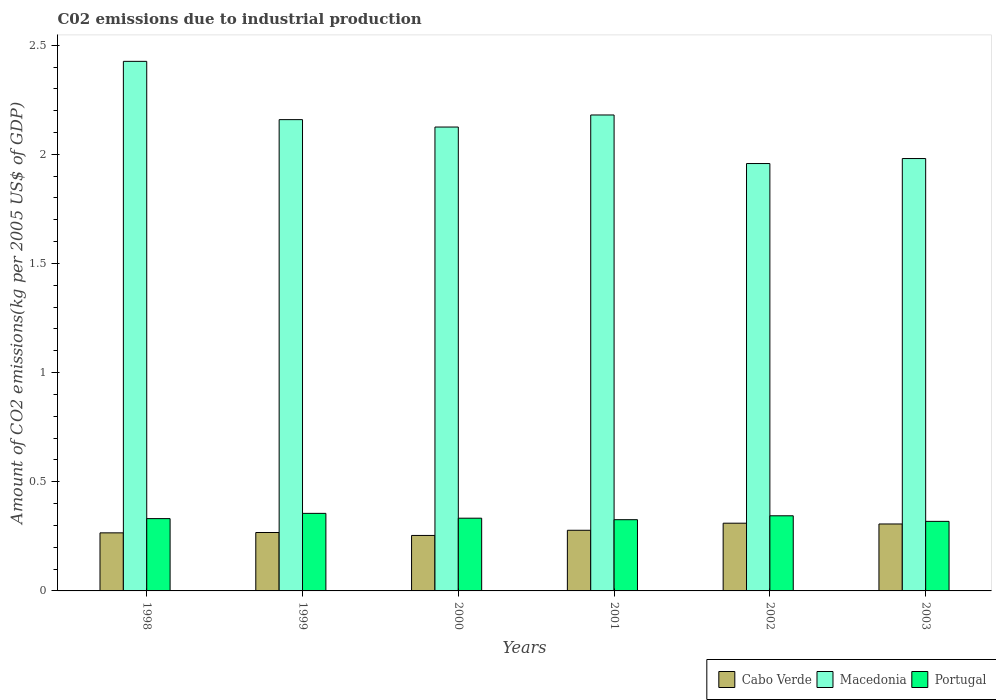How many groups of bars are there?
Keep it short and to the point. 6. How many bars are there on the 4th tick from the right?
Give a very brief answer. 3. What is the amount of CO2 emitted due to industrial production in Macedonia in 2002?
Your response must be concise. 1.96. Across all years, what is the maximum amount of CO2 emitted due to industrial production in Cabo Verde?
Ensure brevity in your answer.  0.31. Across all years, what is the minimum amount of CO2 emitted due to industrial production in Macedonia?
Make the answer very short. 1.96. In which year was the amount of CO2 emitted due to industrial production in Portugal minimum?
Make the answer very short. 2003. What is the total amount of CO2 emitted due to industrial production in Cabo Verde in the graph?
Make the answer very short. 1.68. What is the difference between the amount of CO2 emitted due to industrial production in Macedonia in 2001 and that in 2002?
Give a very brief answer. 0.22. What is the difference between the amount of CO2 emitted due to industrial production in Macedonia in 2003 and the amount of CO2 emitted due to industrial production in Cabo Verde in 2002?
Your answer should be compact. 1.67. What is the average amount of CO2 emitted due to industrial production in Cabo Verde per year?
Offer a very short reply. 0.28. In the year 1998, what is the difference between the amount of CO2 emitted due to industrial production in Macedonia and amount of CO2 emitted due to industrial production in Cabo Verde?
Your response must be concise. 2.16. In how many years, is the amount of CO2 emitted due to industrial production in Macedonia greater than 1.7 kg?
Give a very brief answer. 6. What is the ratio of the amount of CO2 emitted due to industrial production in Macedonia in 2000 to that in 2001?
Make the answer very short. 0.97. Is the amount of CO2 emitted due to industrial production in Macedonia in 2001 less than that in 2003?
Your answer should be very brief. No. Is the difference between the amount of CO2 emitted due to industrial production in Macedonia in 1998 and 2001 greater than the difference between the amount of CO2 emitted due to industrial production in Cabo Verde in 1998 and 2001?
Ensure brevity in your answer.  Yes. What is the difference between the highest and the second highest amount of CO2 emitted due to industrial production in Macedonia?
Your answer should be compact. 0.25. What is the difference between the highest and the lowest amount of CO2 emitted due to industrial production in Cabo Verde?
Ensure brevity in your answer.  0.06. In how many years, is the amount of CO2 emitted due to industrial production in Cabo Verde greater than the average amount of CO2 emitted due to industrial production in Cabo Verde taken over all years?
Your answer should be compact. 2. Is the sum of the amount of CO2 emitted due to industrial production in Macedonia in 2002 and 2003 greater than the maximum amount of CO2 emitted due to industrial production in Cabo Verde across all years?
Offer a terse response. Yes. What does the 1st bar from the left in 2002 represents?
Keep it short and to the point. Cabo Verde. What does the 3rd bar from the right in 1999 represents?
Make the answer very short. Cabo Verde. Is it the case that in every year, the sum of the amount of CO2 emitted due to industrial production in Cabo Verde and amount of CO2 emitted due to industrial production in Macedonia is greater than the amount of CO2 emitted due to industrial production in Portugal?
Your answer should be very brief. Yes. How many years are there in the graph?
Provide a short and direct response. 6. What is the title of the graph?
Keep it short and to the point. C02 emissions due to industrial production. Does "World" appear as one of the legend labels in the graph?
Offer a terse response. No. What is the label or title of the X-axis?
Your answer should be very brief. Years. What is the label or title of the Y-axis?
Offer a terse response. Amount of CO2 emissions(kg per 2005 US$ of GDP). What is the Amount of CO2 emissions(kg per 2005 US$ of GDP) in Cabo Verde in 1998?
Keep it short and to the point. 0.27. What is the Amount of CO2 emissions(kg per 2005 US$ of GDP) of Macedonia in 1998?
Your response must be concise. 2.43. What is the Amount of CO2 emissions(kg per 2005 US$ of GDP) in Portugal in 1998?
Your answer should be compact. 0.33. What is the Amount of CO2 emissions(kg per 2005 US$ of GDP) of Cabo Verde in 1999?
Offer a very short reply. 0.27. What is the Amount of CO2 emissions(kg per 2005 US$ of GDP) in Macedonia in 1999?
Ensure brevity in your answer.  2.16. What is the Amount of CO2 emissions(kg per 2005 US$ of GDP) in Portugal in 1999?
Provide a short and direct response. 0.36. What is the Amount of CO2 emissions(kg per 2005 US$ of GDP) of Cabo Verde in 2000?
Your response must be concise. 0.25. What is the Amount of CO2 emissions(kg per 2005 US$ of GDP) in Macedonia in 2000?
Offer a very short reply. 2.13. What is the Amount of CO2 emissions(kg per 2005 US$ of GDP) in Portugal in 2000?
Offer a terse response. 0.33. What is the Amount of CO2 emissions(kg per 2005 US$ of GDP) of Cabo Verde in 2001?
Your answer should be very brief. 0.28. What is the Amount of CO2 emissions(kg per 2005 US$ of GDP) in Macedonia in 2001?
Make the answer very short. 2.18. What is the Amount of CO2 emissions(kg per 2005 US$ of GDP) in Portugal in 2001?
Provide a succinct answer. 0.33. What is the Amount of CO2 emissions(kg per 2005 US$ of GDP) in Cabo Verde in 2002?
Offer a very short reply. 0.31. What is the Amount of CO2 emissions(kg per 2005 US$ of GDP) in Macedonia in 2002?
Your answer should be compact. 1.96. What is the Amount of CO2 emissions(kg per 2005 US$ of GDP) of Portugal in 2002?
Your answer should be very brief. 0.34. What is the Amount of CO2 emissions(kg per 2005 US$ of GDP) in Cabo Verde in 2003?
Offer a terse response. 0.31. What is the Amount of CO2 emissions(kg per 2005 US$ of GDP) of Macedonia in 2003?
Offer a very short reply. 1.98. What is the Amount of CO2 emissions(kg per 2005 US$ of GDP) in Portugal in 2003?
Make the answer very short. 0.32. Across all years, what is the maximum Amount of CO2 emissions(kg per 2005 US$ of GDP) of Cabo Verde?
Your answer should be very brief. 0.31. Across all years, what is the maximum Amount of CO2 emissions(kg per 2005 US$ of GDP) of Macedonia?
Your response must be concise. 2.43. Across all years, what is the maximum Amount of CO2 emissions(kg per 2005 US$ of GDP) of Portugal?
Offer a very short reply. 0.36. Across all years, what is the minimum Amount of CO2 emissions(kg per 2005 US$ of GDP) of Cabo Verde?
Make the answer very short. 0.25. Across all years, what is the minimum Amount of CO2 emissions(kg per 2005 US$ of GDP) in Macedonia?
Your answer should be compact. 1.96. Across all years, what is the minimum Amount of CO2 emissions(kg per 2005 US$ of GDP) in Portugal?
Your answer should be compact. 0.32. What is the total Amount of CO2 emissions(kg per 2005 US$ of GDP) in Cabo Verde in the graph?
Provide a short and direct response. 1.68. What is the total Amount of CO2 emissions(kg per 2005 US$ of GDP) of Macedonia in the graph?
Keep it short and to the point. 12.83. What is the total Amount of CO2 emissions(kg per 2005 US$ of GDP) in Portugal in the graph?
Give a very brief answer. 2.01. What is the difference between the Amount of CO2 emissions(kg per 2005 US$ of GDP) in Cabo Verde in 1998 and that in 1999?
Provide a succinct answer. -0. What is the difference between the Amount of CO2 emissions(kg per 2005 US$ of GDP) in Macedonia in 1998 and that in 1999?
Provide a succinct answer. 0.27. What is the difference between the Amount of CO2 emissions(kg per 2005 US$ of GDP) in Portugal in 1998 and that in 1999?
Make the answer very short. -0.02. What is the difference between the Amount of CO2 emissions(kg per 2005 US$ of GDP) of Cabo Verde in 1998 and that in 2000?
Provide a succinct answer. 0.01. What is the difference between the Amount of CO2 emissions(kg per 2005 US$ of GDP) of Macedonia in 1998 and that in 2000?
Keep it short and to the point. 0.3. What is the difference between the Amount of CO2 emissions(kg per 2005 US$ of GDP) in Portugal in 1998 and that in 2000?
Ensure brevity in your answer.  -0. What is the difference between the Amount of CO2 emissions(kg per 2005 US$ of GDP) of Cabo Verde in 1998 and that in 2001?
Offer a terse response. -0.01. What is the difference between the Amount of CO2 emissions(kg per 2005 US$ of GDP) of Macedonia in 1998 and that in 2001?
Your response must be concise. 0.25. What is the difference between the Amount of CO2 emissions(kg per 2005 US$ of GDP) in Portugal in 1998 and that in 2001?
Offer a terse response. 0. What is the difference between the Amount of CO2 emissions(kg per 2005 US$ of GDP) of Cabo Verde in 1998 and that in 2002?
Your answer should be compact. -0.04. What is the difference between the Amount of CO2 emissions(kg per 2005 US$ of GDP) in Macedonia in 1998 and that in 2002?
Your answer should be very brief. 0.47. What is the difference between the Amount of CO2 emissions(kg per 2005 US$ of GDP) of Portugal in 1998 and that in 2002?
Your answer should be very brief. -0.01. What is the difference between the Amount of CO2 emissions(kg per 2005 US$ of GDP) of Cabo Verde in 1998 and that in 2003?
Your answer should be compact. -0.04. What is the difference between the Amount of CO2 emissions(kg per 2005 US$ of GDP) of Macedonia in 1998 and that in 2003?
Provide a short and direct response. 0.45. What is the difference between the Amount of CO2 emissions(kg per 2005 US$ of GDP) of Portugal in 1998 and that in 2003?
Offer a very short reply. 0.01. What is the difference between the Amount of CO2 emissions(kg per 2005 US$ of GDP) of Cabo Verde in 1999 and that in 2000?
Give a very brief answer. 0.01. What is the difference between the Amount of CO2 emissions(kg per 2005 US$ of GDP) of Macedonia in 1999 and that in 2000?
Make the answer very short. 0.03. What is the difference between the Amount of CO2 emissions(kg per 2005 US$ of GDP) of Portugal in 1999 and that in 2000?
Make the answer very short. 0.02. What is the difference between the Amount of CO2 emissions(kg per 2005 US$ of GDP) of Cabo Verde in 1999 and that in 2001?
Give a very brief answer. -0.01. What is the difference between the Amount of CO2 emissions(kg per 2005 US$ of GDP) of Macedonia in 1999 and that in 2001?
Ensure brevity in your answer.  -0.02. What is the difference between the Amount of CO2 emissions(kg per 2005 US$ of GDP) of Portugal in 1999 and that in 2001?
Give a very brief answer. 0.03. What is the difference between the Amount of CO2 emissions(kg per 2005 US$ of GDP) in Cabo Verde in 1999 and that in 2002?
Your answer should be very brief. -0.04. What is the difference between the Amount of CO2 emissions(kg per 2005 US$ of GDP) of Macedonia in 1999 and that in 2002?
Your answer should be compact. 0.2. What is the difference between the Amount of CO2 emissions(kg per 2005 US$ of GDP) of Portugal in 1999 and that in 2002?
Your response must be concise. 0.01. What is the difference between the Amount of CO2 emissions(kg per 2005 US$ of GDP) of Cabo Verde in 1999 and that in 2003?
Your answer should be compact. -0.04. What is the difference between the Amount of CO2 emissions(kg per 2005 US$ of GDP) in Macedonia in 1999 and that in 2003?
Your answer should be very brief. 0.18. What is the difference between the Amount of CO2 emissions(kg per 2005 US$ of GDP) of Portugal in 1999 and that in 2003?
Provide a short and direct response. 0.04. What is the difference between the Amount of CO2 emissions(kg per 2005 US$ of GDP) of Cabo Verde in 2000 and that in 2001?
Keep it short and to the point. -0.02. What is the difference between the Amount of CO2 emissions(kg per 2005 US$ of GDP) in Macedonia in 2000 and that in 2001?
Your response must be concise. -0.06. What is the difference between the Amount of CO2 emissions(kg per 2005 US$ of GDP) of Portugal in 2000 and that in 2001?
Your response must be concise. 0.01. What is the difference between the Amount of CO2 emissions(kg per 2005 US$ of GDP) of Cabo Verde in 2000 and that in 2002?
Ensure brevity in your answer.  -0.06. What is the difference between the Amount of CO2 emissions(kg per 2005 US$ of GDP) in Macedonia in 2000 and that in 2002?
Provide a succinct answer. 0.17. What is the difference between the Amount of CO2 emissions(kg per 2005 US$ of GDP) of Portugal in 2000 and that in 2002?
Ensure brevity in your answer.  -0.01. What is the difference between the Amount of CO2 emissions(kg per 2005 US$ of GDP) in Cabo Verde in 2000 and that in 2003?
Provide a short and direct response. -0.05. What is the difference between the Amount of CO2 emissions(kg per 2005 US$ of GDP) in Macedonia in 2000 and that in 2003?
Your answer should be very brief. 0.14. What is the difference between the Amount of CO2 emissions(kg per 2005 US$ of GDP) of Portugal in 2000 and that in 2003?
Offer a very short reply. 0.01. What is the difference between the Amount of CO2 emissions(kg per 2005 US$ of GDP) of Cabo Verde in 2001 and that in 2002?
Your answer should be very brief. -0.03. What is the difference between the Amount of CO2 emissions(kg per 2005 US$ of GDP) of Macedonia in 2001 and that in 2002?
Give a very brief answer. 0.22. What is the difference between the Amount of CO2 emissions(kg per 2005 US$ of GDP) in Portugal in 2001 and that in 2002?
Your answer should be very brief. -0.02. What is the difference between the Amount of CO2 emissions(kg per 2005 US$ of GDP) in Cabo Verde in 2001 and that in 2003?
Offer a terse response. -0.03. What is the difference between the Amount of CO2 emissions(kg per 2005 US$ of GDP) of Macedonia in 2001 and that in 2003?
Provide a succinct answer. 0.2. What is the difference between the Amount of CO2 emissions(kg per 2005 US$ of GDP) of Portugal in 2001 and that in 2003?
Give a very brief answer. 0.01. What is the difference between the Amount of CO2 emissions(kg per 2005 US$ of GDP) of Cabo Verde in 2002 and that in 2003?
Give a very brief answer. 0. What is the difference between the Amount of CO2 emissions(kg per 2005 US$ of GDP) of Macedonia in 2002 and that in 2003?
Keep it short and to the point. -0.02. What is the difference between the Amount of CO2 emissions(kg per 2005 US$ of GDP) in Portugal in 2002 and that in 2003?
Keep it short and to the point. 0.03. What is the difference between the Amount of CO2 emissions(kg per 2005 US$ of GDP) of Cabo Verde in 1998 and the Amount of CO2 emissions(kg per 2005 US$ of GDP) of Macedonia in 1999?
Provide a short and direct response. -1.89. What is the difference between the Amount of CO2 emissions(kg per 2005 US$ of GDP) in Cabo Verde in 1998 and the Amount of CO2 emissions(kg per 2005 US$ of GDP) in Portugal in 1999?
Provide a succinct answer. -0.09. What is the difference between the Amount of CO2 emissions(kg per 2005 US$ of GDP) in Macedonia in 1998 and the Amount of CO2 emissions(kg per 2005 US$ of GDP) in Portugal in 1999?
Your response must be concise. 2.07. What is the difference between the Amount of CO2 emissions(kg per 2005 US$ of GDP) of Cabo Verde in 1998 and the Amount of CO2 emissions(kg per 2005 US$ of GDP) of Macedonia in 2000?
Ensure brevity in your answer.  -1.86. What is the difference between the Amount of CO2 emissions(kg per 2005 US$ of GDP) in Cabo Verde in 1998 and the Amount of CO2 emissions(kg per 2005 US$ of GDP) in Portugal in 2000?
Make the answer very short. -0.07. What is the difference between the Amount of CO2 emissions(kg per 2005 US$ of GDP) in Macedonia in 1998 and the Amount of CO2 emissions(kg per 2005 US$ of GDP) in Portugal in 2000?
Offer a terse response. 2.09. What is the difference between the Amount of CO2 emissions(kg per 2005 US$ of GDP) in Cabo Verde in 1998 and the Amount of CO2 emissions(kg per 2005 US$ of GDP) in Macedonia in 2001?
Ensure brevity in your answer.  -1.91. What is the difference between the Amount of CO2 emissions(kg per 2005 US$ of GDP) of Cabo Verde in 1998 and the Amount of CO2 emissions(kg per 2005 US$ of GDP) of Portugal in 2001?
Your answer should be very brief. -0.06. What is the difference between the Amount of CO2 emissions(kg per 2005 US$ of GDP) of Macedonia in 1998 and the Amount of CO2 emissions(kg per 2005 US$ of GDP) of Portugal in 2001?
Your answer should be compact. 2.1. What is the difference between the Amount of CO2 emissions(kg per 2005 US$ of GDP) in Cabo Verde in 1998 and the Amount of CO2 emissions(kg per 2005 US$ of GDP) in Macedonia in 2002?
Provide a succinct answer. -1.69. What is the difference between the Amount of CO2 emissions(kg per 2005 US$ of GDP) of Cabo Verde in 1998 and the Amount of CO2 emissions(kg per 2005 US$ of GDP) of Portugal in 2002?
Your answer should be very brief. -0.08. What is the difference between the Amount of CO2 emissions(kg per 2005 US$ of GDP) of Macedonia in 1998 and the Amount of CO2 emissions(kg per 2005 US$ of GDP) of Portugal in 2002?
Keep it short and to the point. 2.08. What is the difference between the Amount of CO2 emissions(kg per 2005 US$ of GDP) of Cabo Verde in 1998 and the Amount of CO2 emissions(kg per 2005 US$ of GDP) of Macedonia in 2003?
Provide a short and direct response. -1.71. What is the difference between the Amount of CO2 emissions(kg per 2005 US$ of GDP) in Cabo Verde in 1998 and the Amount of CO2 emissions(kg per 2005 US$ of GDP) in Portugal in 2003?
Offer a terse response. -0.05. What is the difference between the Amount of CO2 emissions(kg per 2005 US$ of GDP) of Macedonia in 1998 and the Amount of CO2 emissions(kg per 2005 US$ of GDP) of Portugal in 2003?
Provide a succinct answer. 2.11. What is the difference between the Amount of CO2 emissions(kg per 2005 US$ of GDP) of Cabo Verde in 1999 and the Amount of CO2 emissions(kg per 2005 US$ of GDP) of Macedonia in 2000?
Provide a succinct answer. -1.86. What is the difference between the Amount of CO2 emissions(kg per 2005 US$ of GDP) of Cabo Verde in 1999 and the Amount of CO2 emissions(kg per 2005 US$ of GDP) of Portugal in 2000?
Your answer should be compact. -0.07. What is the difference between the Amount of CO2 emissions(kg per 2005 US$ of GDP) of Macedonia in 1999 and the Amount of CO2 emissions(kg per 2005 US$ of GDP) of Portugal in 2000?
Provide a short and direct response. 1.83. What is the difference between the Amount of CO2 emissions(kg per 2005 US$ of GDP) in Cabo Verde in 1999 and the Amount of CO2 emissions(kg per 2005 US$ of GDP) in Macedonia in 2001?
Your answer should be very brief. -1.91. What is the difference between the Amount of CO2 emissions(kg per 2005 US$ of GDP) in Cabo Verde in 1999 and the Amount of CO2 emissions(kg per 2005 US$ of GDP) in Portugal in 2001?
Your response must be concise. -0.06. What is the difference between the Amount of CO2 emissions(kg per 2005 US$ of GDP) in Macedonia in 1999 and the Amount of CO2 emissions(kg per 2005 US$ of GDP) in Portugal in 2001?
Make the answer very short. 1.83. What is the difference between the Amount of CO2 emissions(kg per 2005 US$ of GDP) of Cabo Verde in 1999 and the Amount of CO2 emissions(kg per 2005 US$ of GDP) of Macedonia in 2002?
Make the answer very short. -1.69. What is the difference between the Amount of CO2 emissions(kg per 2005 US$ of GDP) of Cabo Verde in 1999 and the Amount of CO2 emissions(kg per 2005 US$ of GDP) of Portugal in 2002?
Your answer should be compact. -0.08. What is the difference between the Amount of CO2 emissions(kg per 2005 US$ of GDP) in Macedonia in 1999 and the Amount of CO2 emissions(kg per 2005 US$ of GDP) in Portugal in 2002?
Provide a succinct answer. 1.81. What is the difference between the Amount of CO2 emissions(kg per 2005 US$ of GDP) in Cabo Verde in 1999 and the Amount of CO2 emissions(kg per 2005 US$ of GDP) in Macedonia in 2003?
Provide a short and direct response. -1.71. What is the difference between the Amount of CO2 emissions(kg per 2005 US$ of GDP) of Cabo Verde in 1999 and the Amount of CO2 emissions(kg per 2005 US$ of GDP) of Portugal in 2003?
Provide a short and direct response. -0.05. What is the difference between the Amount of CO2 emissions(kg per 2005 US$ of GDP) of Macedonia in 1999 and the Amount of CO2 emissions(kg per 2005 US$ of GDP) of Portugal in 2003?
Keep it short and to the point. 1.84. What is the difference between the Amount of CO2 emissions(kg per 2005 US$ of GDP) of Cabo Verde in 2000 and the Amount of CO2 emissions(kg per 2005 US$ of GDP) of Macedonia in 2001?
Your response must be concise. -1.93. What is the difference between the Amount of CO2 emissions(kg per 2005 US$ of GDP) of Cabo Verde in 2000 and the Amount of CO2 emissions(kg per 2005 US$ of GDP) of Portugal in 2001?
Ensure brevity in your answer.  -0.07. What is the difference between the Amount of CO2 emissions(kg per 2005 US$ of GDP) of Macedonia in 2000 and the Amount of CO2 emissions(kg per 2005 US$ of GDP) of Portugal in 2001?
Give a very brief answer. 1.8. What is the difference between the Amount of CO2 emissions(kg per 2005 US$ of GDP) of Cabo Verde in 2000 and the Amount of CO2 emissions(kg per 2005 US$ of GDP) of Macedonia in 2002?
Offer a very short reply. -1.7. What is the difference between the Amount of CO2 emissions(kg per 2005 US$ of GDP) in Cabo Verde in 2000 and the Amount of CO2 emissions(kg per 2005 US$ of GDP) in Portugal in 2002?
Give a very brief answer. -0.09. What is the difference between the Amount of CO2 emissions(kg per 2005 US$ of GDP) in Macedonia in 2000 and the Amount of CO2 emissions(kg per 2005 US$ of GDP) in Portugal in 2002?
Your answer should be compact. 1.78. What is the difference between the Amount of CO2 emissions(kg per 2005 US$ of GDP) of Cabo Verde in 2000 and the Amount of CO2 emissions(kg per 2005 US$ of GDP) of Macedonia in 2003?
Provide a short and direct response. -1.73. What is the difference between the Amount of CO2 emissions(kg per 2005 US$ of GDP) in Cabo Verde in 2000 and the Amount of CO2 emissions(kg per 2005 US$ of GDP) in Portugal in 2003?
Your response must be concise. -0.06. What is the difference between the Amount of CO2 emissions(kg per 2005 US$ of GDP) in Macedonia in 2000 and the Amount of CO2 emissions(kg per 2005 US$ of GDP) in Portugal in 2003?
Your answer should be compact. 1.81. What is the difference between the Amount of CO2 emissions(kg per 2005 US$ of GDP) of Cabo Verde in 2001 and the Amount of CO2 emissions(kg per 2005 US$ of GDP) of Macedonia in 2002?
Provide a short and direct response. -1.68. What is the difference between the Amount of CO2 emissions(kg per 2005 US$ of GDP) of Cabo Verde in 2001 and the Amount of CO2 emissions(kg per 2005 US$ of GDP) of Portugal in 2002?
Provide a short and direct response. -0.07. What is the difference between the Amount of CO2 emissions(kg per 2005 US$ of GDP) in Macedonia in 2001 and the Amount of CO2 emissions(kg per 2005 US$ of GDP) in Portugal in 2002?
Give a very brief answer. 1.84. What is the difference between the Amount of CO2 emissions(kg per 2005 US$ of GDP) in Cabo Verde in 2001 and the Amount of CO2 emissions(kg per 2005 US$ of GDP) in Macedonia in 2003?
Make the answer very short. -1.7. What is the difference between the Amount of CO2 emissions(kg per 2005 US$ of GDP) in Cabo Verde in 2001 and the Amount of CO2 emissions(kg per 2005 US$ of GDP) in Portugal in 2003?
Make the answer very short. -0.04. What is the difference between the Amount of CO2 emissions(kg per 2005 US$ of GDP) in Macedonia in 2001 and the Amount of CO2 emissions(kg per 2005 US$ of GDP) in Portugal in 2003?
Your answer should be compact. 1.86. What is the difference between the Amount of CO2 emissions(kg per 2005 US$ of GDP) in Cabo Verde in 2002 and the Amount of CO2 emissions(kg per 2005 US$ of GDP) in Macedonia in 2003?
Ensure brevity in your answer.  -1.67. What is the difference between the Amount of CO2 emissions(kg per 2005 US$ of GDP) of Cabo Verde in 2002 and the Amount of CO2 emissions(kg per 2005 US$ of GDP) of Portugal in 2003?
Ensure brevity in your answer.  -0.01. What is the difference between the Amount of CO2 emissions(kg per 2005 US$ of GDP) in Macedonia in 2002 and the Amount of CO2 emissions(kg per 2005 US$ of GDP) in Portugal in 2003?
Provide a short and direct response. 1.64. What is the average Amount of CO2 emissions(kg per 2005 US$ of GDP) in Cabo Verde per year?
Your answer should be compact. 0.28. What is the average Amount of CO2 emissions(kg per 2005 US$ of GDP) in Macedonia per year?
Make the answer very short. 2.14. What is the average Amount of CO2 emissions(kg per 2005 US$ of GDP) in Portugal per year?
Your answer should be compact. 0.33. In the year 1998, what is the difference between the Amount of CO2 emissions(kg per 2005 US$ of GDP) of Cabo Verde and Amount of CO2 emissions(kg per 2005 US$ of GDP) of Macedonia?
Ensure brevity in your answer.  -2.16. In the year 1998, what is the difference between the Amount of CO2 emissions(kg per 2005 US$ of GDP) of Cabo Verde and Amount of CO2 emissions(kg per 2005 US$ of GDP) of Portugal?
Your response must be concise. -0.07. In the year 1998, what is the difference between the Amount of CO2 emissions(kg per 2005 US$ of GDP) in Macedonia and Amount of CO2 emissions(kg per 2005 US$ of GDP) in Portugal?
Provide a succinct answer. 2.09. In the year 1999, what is the difference between the Amount of CO2 emissions(kg per 2005 US$ of GDP) in Cabo Verde and Amount of CO2 emissions(kg per 2005 US$ of GDP) in Macedonia?
Ensure brevity in your answer.  -1.89. In the year 1999, what is the difference between the Amount of CO2 emissions(kg per 2005 US$ of GDP) of Cabo Verde and Amount of CO2 emissions(kg per 2005 US$ of GDP) of Portugal?
Your answer should be very brief. -0.09. In the year 1999, what is the difference between the Amount of CO2 emissions(kg per 2005 US$ of GDP) of Macedonia and Amount of CO2 emissions(kg per 2005 US$ of GDP) of Portugal?
Offer a terse response. 1.8. In the year 2000, what is the difference between the Amount of CO2 emissions(kg per 2005 US$ of GDP) in Cabo Verde and Amount of CO2 emissions(kg per 2005 US$ of GDP) in Macedonia?
Provide a succinct answer. -1.87. In the year 2000, what is the difference between the Amount of CO2 emissions(kg per 2005 US$ of GDP) of Cabo Verde and Amount of CO2 emissions(kg per 2005 US$ of GDP) of Portugal?
Provide a succinct answer. -0.08. In the year 2000, what is the difference between the Amount of CO2 emissions(kg per 2005 US$ of GDP) of Macedonia and Amount of CO2 emissions(kg per 2005 US$ of GDP) of Portugal?
Your response must be concise. 1.79. In the year 2001, what is the difference between the Amount of CO2 emissions(kg per 2005 US$ of GDP) of Cabo Verde and Amount of CO2 emissions(kg per 2005 US$ of GDP) of Macedonia?
Your answer should be compact. -1.9. In the year 2001, what is the difference between the Amount of CO2 emissions(kg per 2005 US$ of GDP) of Cabo Verde and Amount of CO2 emissions(kg per 2005 US$ of GDP) of Portugal?
Your answer should be very brief. -0.05. In the year 2001, what is the difference between the Amount of CO2 emissions(kg per 2005 US$ of GDP) in Macedonia and Amount of CO2 emissions(kg per 2005 US$ of GDP) in Portugal?
Ensure brevity in your answer.  1.85. In the year 2002, what is the difference between the Amount of CO2 emissions(kg per 2005 US$ of GDP) in Cabo Verde and Amount of CO2 emissions(kg per 2005 US$ of GDP) in Macedonia?
Make the answer very short. -1.65. In the year 2002, what is the difference between the Amount of CO2 emissions(kg per 2005 US$ of GDP) in Cabo Verde and Amount of CO2 emissions(kg per 2005 US$ of GDP) in Portugal?
Provide a short and direct response. -0.03. In the year 2002, what is the difference between the Amount of CO2 emissions(kg per 2005 US$ of GDP) in Macedonia and Amount of CO2 emissions(kg per 2005 US$ of GDP) in Portugal?
Offer a terse response. 1.61. In the year 2003, what is the difference between the Amount of CO2 emissions(kg per 2005 US$ of GDP) in Cabo Verde and Amount of CO2 emissions(kg per 2005 US$ of GDP) in Macedonia?
Give a very brief answer. -1.67. In the year 2003, what is the difference between the Amount of CO2 emissions(kg per 2005 US$ of GDP) in Cabo Verde and Amount of CO2 emissions(kg per 2005 US$ of GDP) in Portugal?
Offer a terse response. -0.01. In the year 2003, what is the difference between the Amount of CO2 emissions(kg per 2005 US$ of GDP) of Macedonia and Amount of CO2 emissions(kg per 2005 US$ of GDP) of Portugal?
Give a very brief answer. 1.66. What is the ratio of the Amount of CO2 emissions(kg per 2005 US$ of GDP) in Macedonia in 1998 to that in 1999?
Provide a short and direct response. 1.12. What is the ratio of the Amount of CO2 emissions(kg per 2005 US$ of GDP) in Portugal in 1998 to that in 1999?
Provide a short and direct response. 0.93. What is the ratio of the Amount of CO2 emissions(kg per 2005 US$ of GDP) in Cabo Verde in 1998 to that in 2000?
Offer a terse response. 1.05. What is the ratio of the Amount of CO2 emissions(kg per 2005 US$ of GDP) of Macedonia in 1998 to that in 2000?
Ensure brevity in your answer.  1.14. What is the ratio of the Amount of CO2 emissions(kg per 2005 US$ of GDP) of Portugal in 1998 to that in 2000?
Your answer should be very brief. 0.99. What is the ratio of the Amount of CO2 emissions(kg per 2005 US$ of GDP) in Cabo Verde in 1998 to that in 2001?
Ensure brevity in your answer.  0.96. What is the ratio of the Amount of CO2 emissions(kg per 2005 US$ of GDP) of Macedonia in 1998 to that in 2001?
Offer a terse response. 1.11. What is the ratio of the Amount of CO2 emissions(kg per 2005 US$ of GDP) of Portugal in 1998 to that in 2001?
Ensure brevity in your answer.  1.02. What is the ratio of the Amount of CO2 emissions(kg per 2005 US$ of GDP) of Cabo Verde in 1998 to that in 2002?
Ensure brevity in your answer.  0.86. What is the ratio of the Amount of CO2 emissions(kg per 2005 US$ of GDP) of Macedonia in 1998 to that in 2002?
Make the answer very short. 1.24. What is the ratio of the Amount of CO2 emissions(kg per 2005 US$ of GDP) in Portugal in 1998 to that in 2002?
Make the answer very short. 0.96. What is the ratio of the Amount of CO2 emissions(kg per 2005 US$ of GDP) in Cabo Verde in 1998 to that in 2003?
Provide a short and direct response. 0.87. What is the ratio of the Amount of CO2 emissions(kg per 2005 US$ of GDP) of Macedonia in 1998 to that in 2003?
Keep it short and to the point. 1.22. What is the ratio of the Amount of CO2 emissions(kg per 2005 US$ of GDP) of Portugal in 1998 to that in 2003?
Offer a terse response. 1.04. What is the ratio of the Amount of CO2 emissions(kg per 2005 US$ of GDP) of Cabo Verde in 1999 to that in 2000?
Keep it short and to the point. 1.05. What is the ratio of the Amount of CO2 emissions(kg per 2005 US$ of GDP) in Macedonia in 1999 to that in 2000?
Provide a short and direct response. 1.02. What is the ratio of the Amount of CO2 emissions(kg per 2005 US$ of GDP) of Portugal in 1999 to that in 2000?
Your response must be concise. 1.07. What is the ratio of the Amount of CO2 emissions(kg per 2005 US$ of GDP) in Cabo Verde in 1999 to that in 2001?
Provide a short and direct response. 0.96. What is the ratio of the Amount of CO2 emissions(kg per 2005 US$ of GDP) of Macedonia in 1999 to that in 2001?
Your answer should be compact. 0.99. What is the ratio of the Amount of CO2 emissions(kg per 2005 US$ of GDP) in Portugal in 1999 to that in 2001?
Your answer should be compact. 1.09. What is the ratio of the Amount of CO2 emissions(kg per 2005 US$ of GDP) in Cabo Verde in 1999 to that in 2002?
Your answer should be very brief. 0.86. What is the ratio of the Amount of CO2 emissions(kg per 2005 US$ of GDP) in Macedonia in 1999 to that in 2002?
Offer a terse response. 1.1. What is the ratio of the Amount of CO2 emissions(kg per 2005 US$ of GDP) of Portugal in 1999 to that in 2002?
Provide a short and direct response. 1.03. What is the ratio of the Amount of CO2 emissions(kg per 2005 US$ of GDP) of Cabo Verde in 1999 to that in 2003?
Provide a short and direct response. 0.87. What is the ratio of the Amount of CO2 emissions(kg per 2005 US$ of GDP) of Macedonia in 1999 to that in 2003?
Provide a short and direct response. 1.09. What is the ratio of the Amount of CO2 emissions(kg per 2005 US$ of GDP) in Portugal in 1999 to that in 2003?
Keep it short and to the point. 1.12. What is the ratio of the Amount of CO2 emissions(kg per 2005 US$ of GDP) of Cabo Verde in 2000 to that in 2001?
Keep it short and to the point. 0.91. What is the ratio of the Amount of CO2 emissions(kg per 2005 US$ of GDP) of Macedonia in 2000 to that in 2001?
Provide a succinct answer. 0.97. What is the ratio of the Amount of CO2 emissions(kg per 2005 US$ of GDP) of Portugal in 2000 to that in 2001?
Your answer should be very brief. 1.02. What is the ratio of the Amount of CO2 emissions(kg per 2005 US$ of GDP) of Cabo Verde in 2000 to that in 2002?
Your answer should be very brief. 0.82. What is the ratio of the Amount of CO2 emissions(kg per 2005 US$ of GDP) of Macedonia in 2000 to that in 2002?
Your response must be concise. 1.09. What is the ratio of the Amount of CO2 emissions(kg per 2005 US$ of GDP) in Portugal in 2000 to that in 2002?
Your answer should be very brief. 0.97. What is the ratio of the Amount of CO2 emissions(kg per 2005 US$ of GDP) of Cabo Verde in 2000 to that in 2003?
Ensure brevity in your answer.  0.83. What is the ratio of the Amount of CO2 emissions(kg per 2005 US$ of GDP) in Macedonia in 2000 to that in 2003?
Ensure brevity in your answer.  1.07. What is the ratio of the Amount of CO2 emissions(kg per 2005 US$ of GDP) in Portugal in 2000 to that in 2003?
Offer a terse response. 1.05. What is the ratio of the Amount of CO2 emissions(kg per 2005 US$ of GDP) of Cabo Verde in 2001 to that in 2002?
Offer a very short reply. 0.9. What is the ratio of the Amount of CO2 emissions(kg per 2005 US$ of GDP) of Macedonia in 2001 to that in 2002?
Your answer should be very brief. 1.11. What is the ratio of the Amount of CO2 emissions(kg per 2005 US$ of GDP) of Portugal in 2001 to that in 2002?
Ensure brevity in your answer.  0.95. What is the ratio of the Amount of CO2 emissions(kg per 2005 US$ of GDP) in Cabo Verde in 2001 to that in 2003?
Keep it short and to the point. 0.91. What is the ratio of the Amount of CO2 emissions(kg per 2005 US$ of GDP) in Macedonia in 2001 to that in 2003?
Your response must be concise. 1.1. What is the ratio of the Amount of CO2 emissions(kg per 2005 US$ of GDP) of Portugal in 2001 to that in 2003?
Offer a terse response. 1.02. What is the ratio of the Amount of CO2 emissions(kg per 2005 US$ of GDP) of Cabo Verde in 2002 to that in 2003?
Your answer should be very brief. 1.01. What is the ratio of the Amount of CO2 emissions(kg per 2005 US$ of GDP) of Macedonia in 2002 to that in 2003?
Keep it short and to the point. 0.99. What is the ratio of the Amount of CO2 emissions(kg per 2005 US$ of GDP) of Portugal in 2002 to that in 2003?
Provide a succinct answer. 1.08. What is the difference between the highest and the second highest Amount of CO2 emissions(kg per 2005 US$ of GDP) in Cabo Verde?
Provide a succinct answer. 0. What is the difference between the highest and the second highest Amount of CO2 emissions(kg per 2005 US$ of GDP) in Macedonia?
Your answer should be compact. 0.25. What is the difference between the highest and the second highest Amount of CO2 emissions(kg per 2005 US$ of GDP) in Portugal?
Your answer should be very brief. 0.01. What is the difference between the highest and the lowest Amount of CO2 emissions(kg per 2005 US$ of GDP) of Cabo Verde?
Ensure brevity in your answer.  0.06. What is the difference between the highest and the lowest Amount of CO2 emissions(kg per 2005 US$ of GDP) in Macedonia?
Your response must be concise. 0.47. What is the difference between the highest and the lowest Amount of CO2 emissions(kg per 2005 US$ of GDP) of Portugal?
Provide a short and direct response. 0.04. 